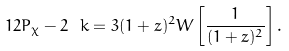<formula> <loc_0><loc_0><loc_500><loc_500>1 2 P _ { \chi } - 2 \ k = 3 ( 1 + z ) ^ { 2 } W \left [ \frac { 1 } { ( 1 + z ) ^ { 2 } } \right ] .</formula> 